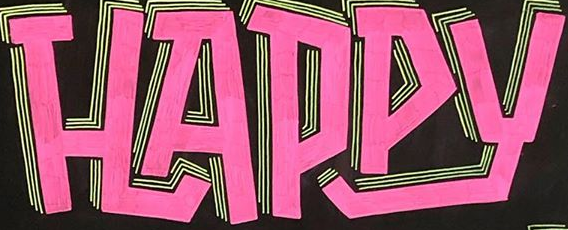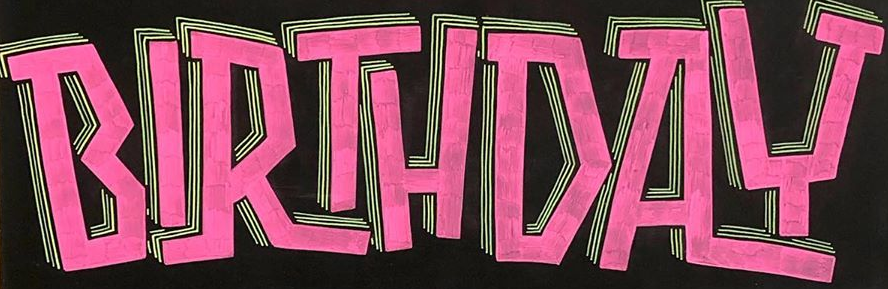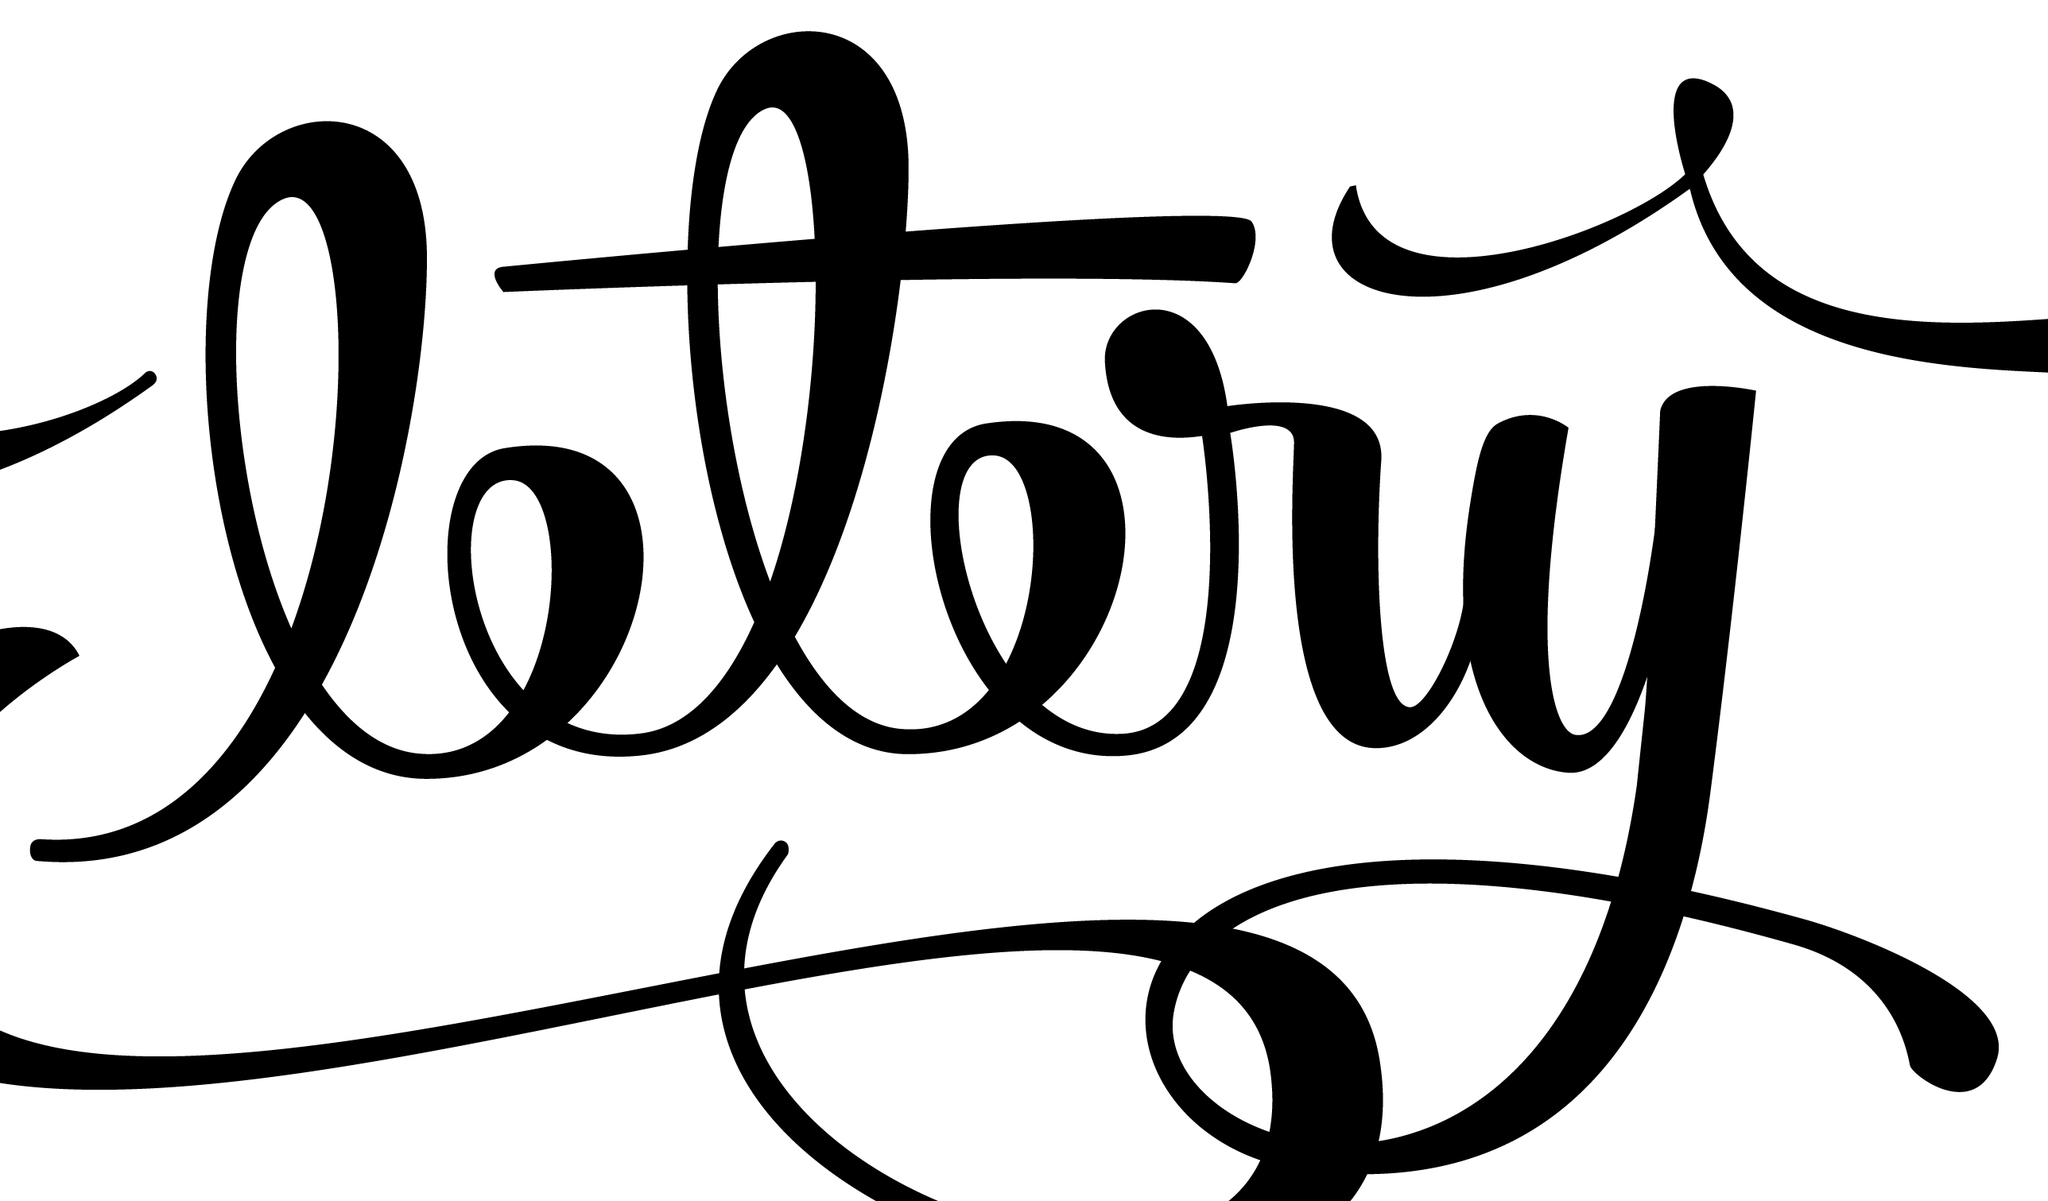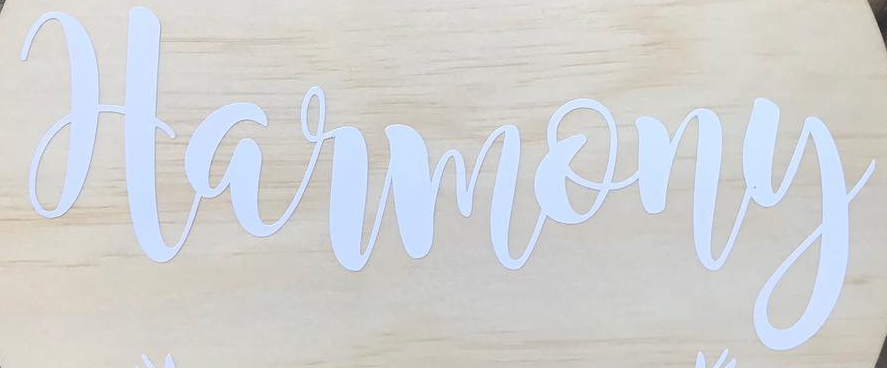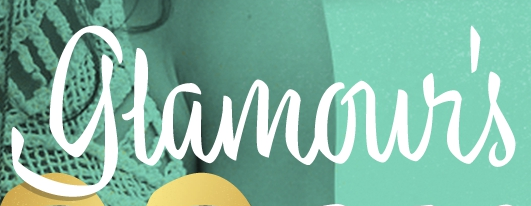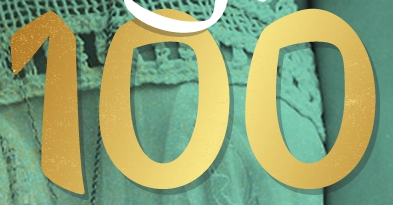What text appears in these images from left to right, separated by a semicolon? HAPPY; BIRTHDAY; ltry; Harmony; glamour's; 100 